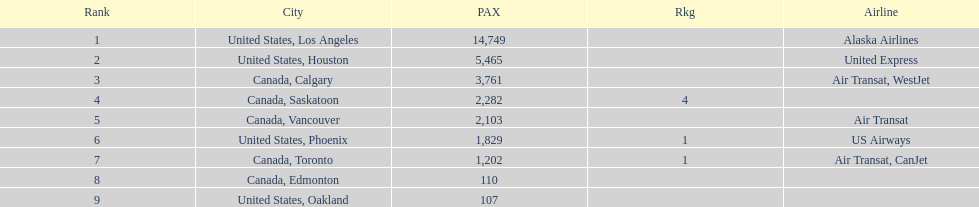How many cities from canada are on this list? 5. 